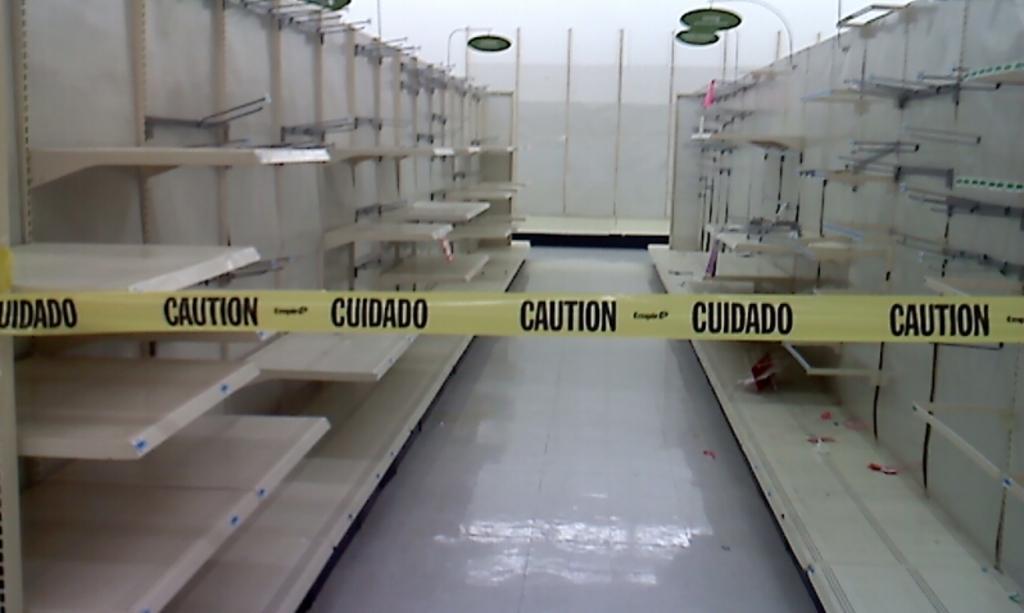In one or two sentences, can you explain what this image depicts? In the center of the image we can see construction safety tag. On the left and right side of the image we can see shelves. In the background there is wall. 